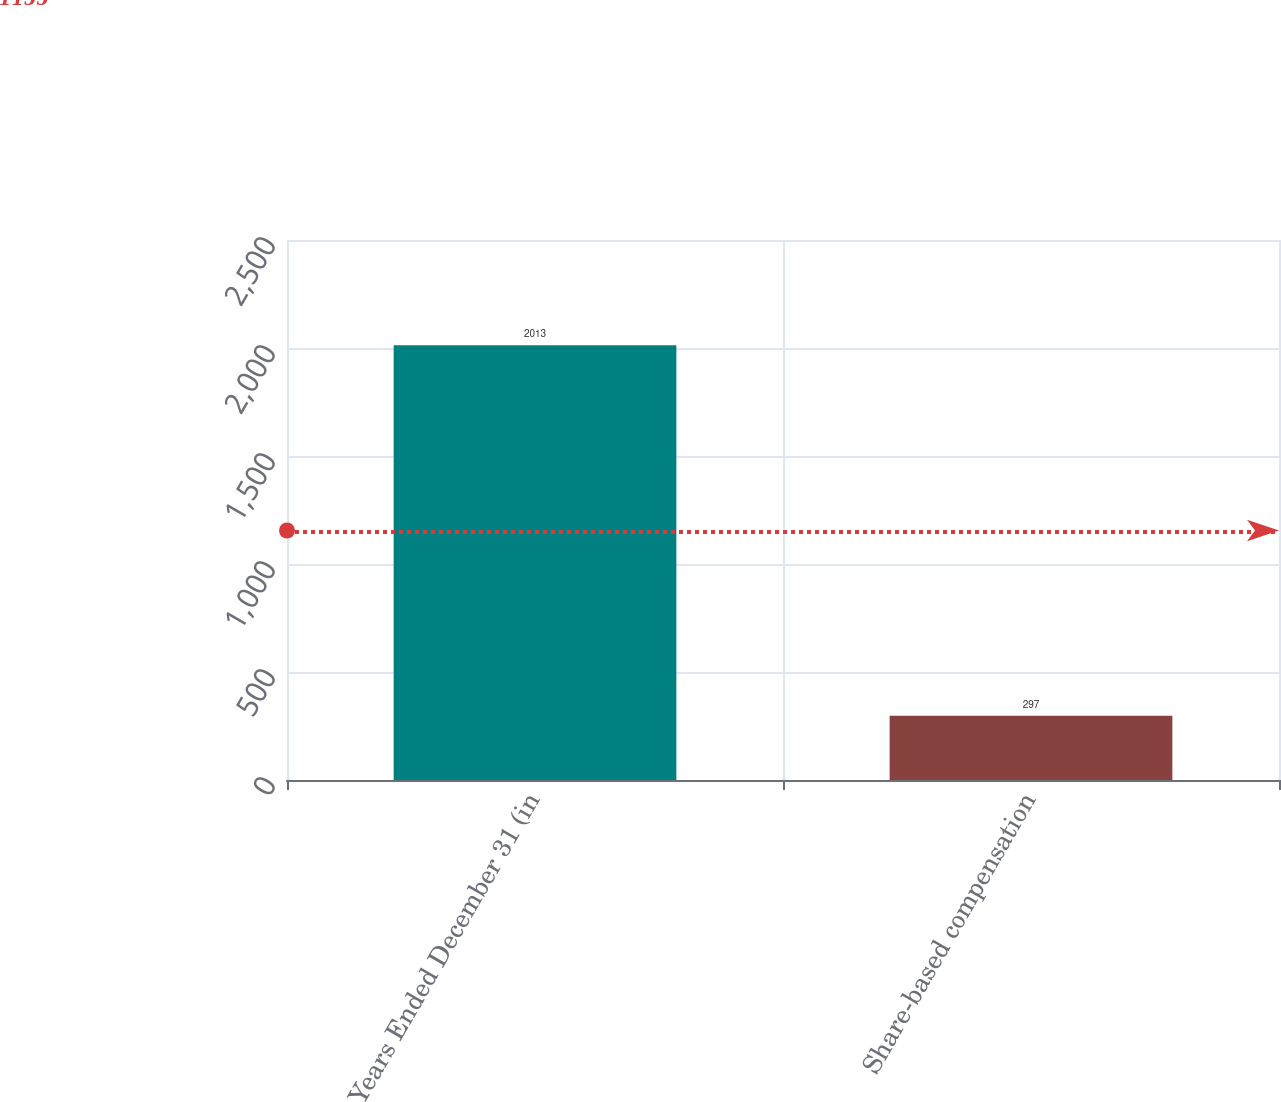Convert chart. <chart><loc_0><loc_0><loc_500><loc_500><bar_chart><fcel>Years Ended December 31 (in<fcel>Share-based compensation<nl><fcel>2013<fcel>297<nl></chart> 